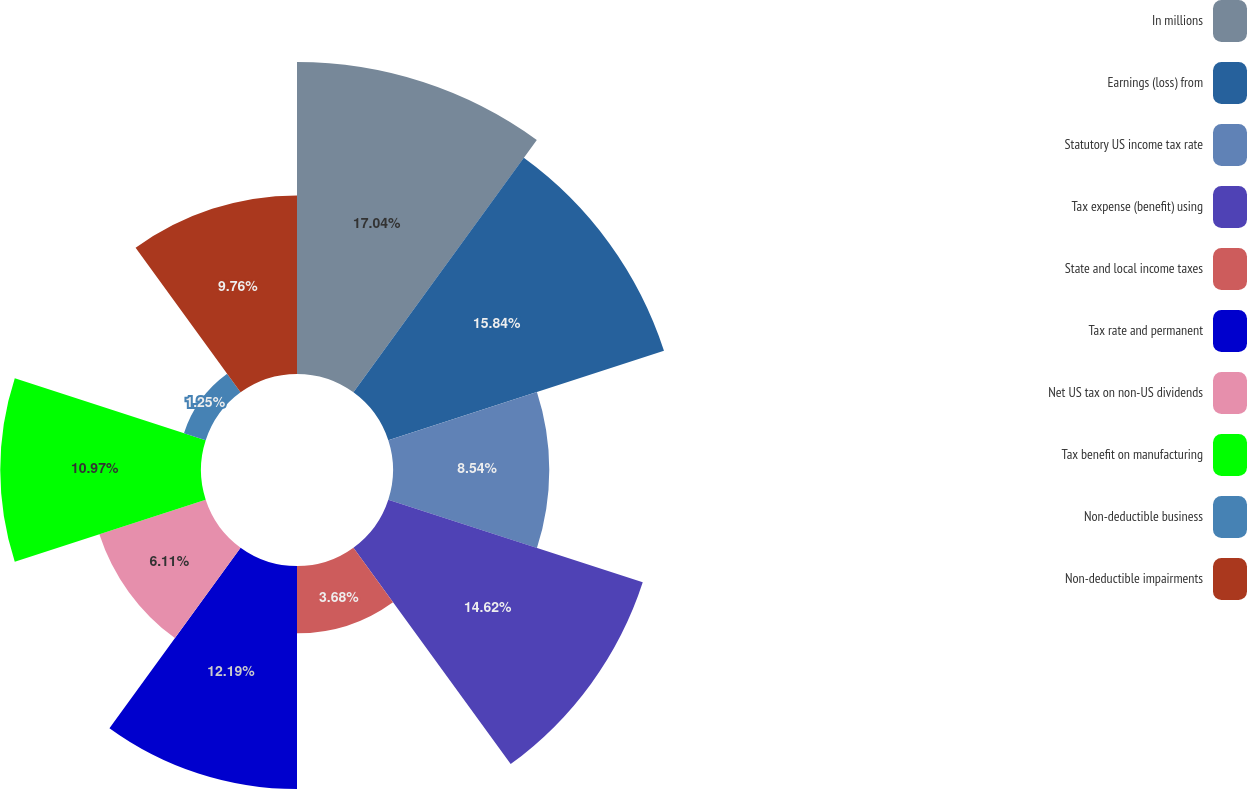<chart> <loc_0><loc_0><loc_500><loc_500><pie_chart><fcel>In millions<fcel>Earnings (loss) from<fcel>Statutory US income tax rate<fcel>Tax expense (benefit) using<fcel>State and local income taxes<fcel>Tax rate and permanent<fcel>Net US tax on non-US dividends<fcel>Tax benefit on manufacturing<fcel>Non-deductible business<fcel>Non-deductible impairments<nl><fcel>17.05%<fcel>15.84%<fcel>8.54%<fcel>14.62%<fcel>3.68%<fcel>12.19%<fcel>6.11%<fcel>10.97%<fcel>1.25%<fcel>9.76%<nl></chart> 